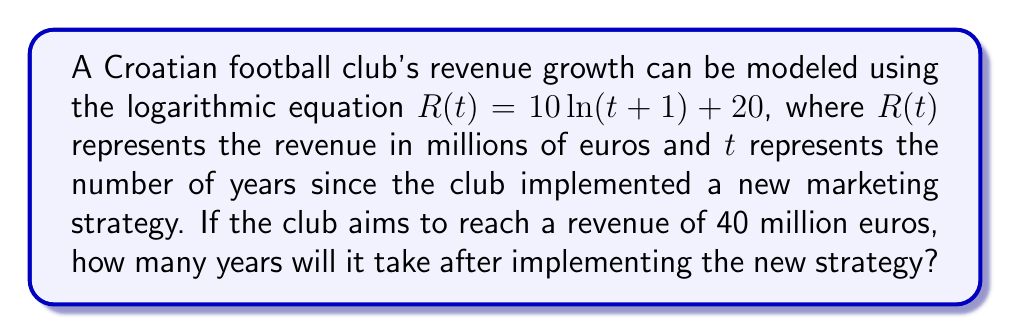What is the answer to this math problem? To solve this problem, we need to follow these steps:

1) We are given the equation: $R(t) = 10 \ln(t+1) + 20$

2) We want to find $t$ when $R(t) = 40$. So, let's substitute this:

   $40 = 10 \ln(t+1) + 20$

3) Subtract 20 from both sides:

   $20 = 10 \ln(t+1)$

4) Divide both sides by 10:

   $2 = \ln(t+1)$

5) To solve for $t$, we need to apply the exponential function (e^) to both sides. This is because $e^{\ln(x)} = x$:

   $e^2 = e^{\ln(t+1)}$
   $e^2 = t+1$

6) Subtract 1 from both sides:

   $e^2 - 1 = t$

7) Calculate the value:

   $t = e^2 - 1 \approx 7.3891 - 1 = 6.3891$

8) Since we're dealing with years, we need to round up to the nearest whole year.
Answer: It will take 7 years for the club to reach a revenue of 40 million euros after implementing the new marketing strategy. 